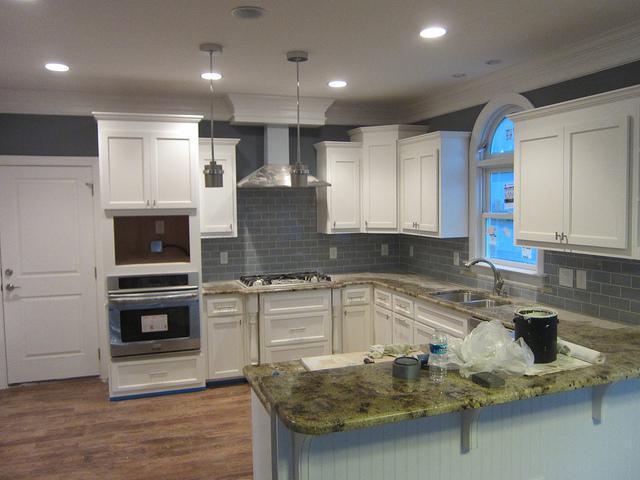How many cats are shown?
Give a very brief answer. 0. 